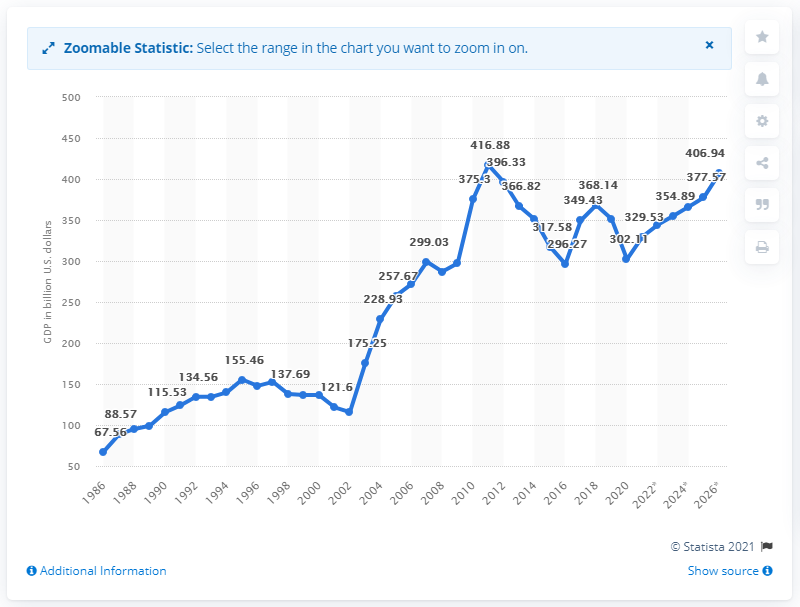Mention a couple of crucial points in this snapshot. The Gross Domestic Product (GDP) of South Africa in 2020 was 302.11 billion dollars. 